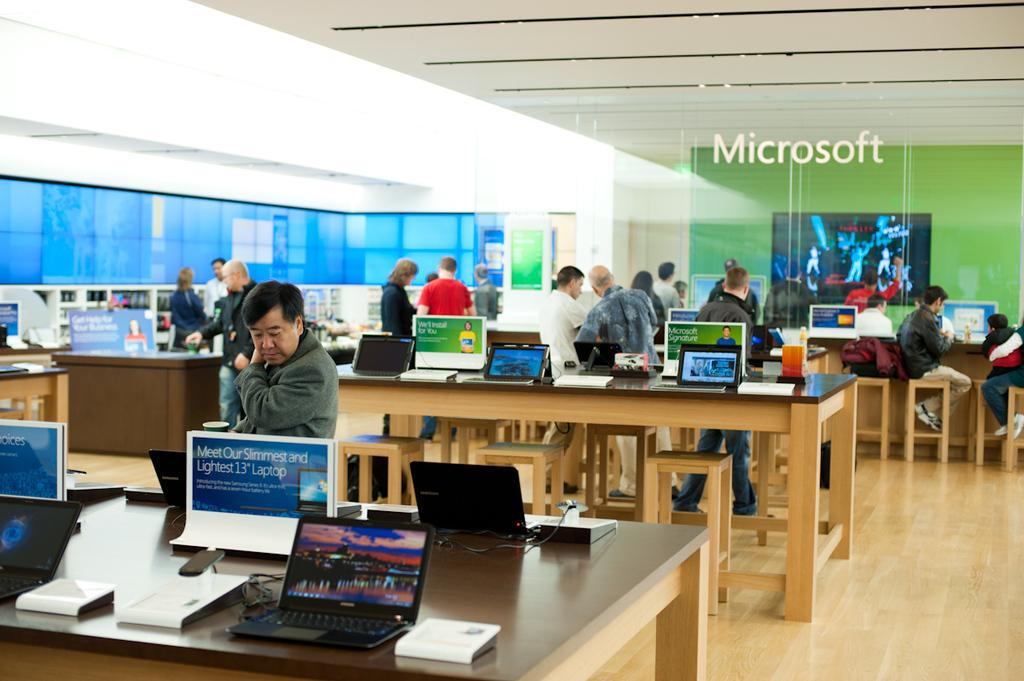What electronic devices are placed on the table in the image? There are laptops placed on a table in the image. What might the people standing near the table be doing? The people standing near the table might be using or discussing the laptops. How many cherries are on top of the laptops in the image? There are no cherries present on top of the laptops in the image. 